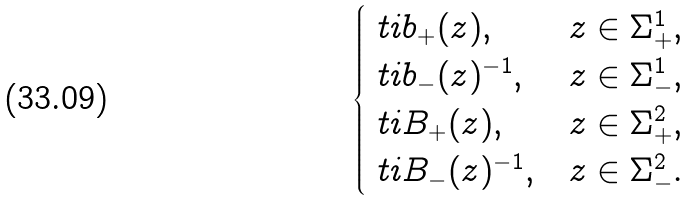Convert formula to latex. <formula><loc_0><loc_0><loc_500><loc_500>\begin{cases} \ t i { b } _ { + } ( z ) , & z \in \Sigma _ { + } ^ { 1 } , \\ \ t i { b } _ { - } ( z ) ^ { - 1 } , & z \in \Sigma _ { - } ^ { 1 } , \\ \ t i { B } _ { + } ( z ) , & z \in \Sigma _ { + } ^ { 2 } , \\ \ t i { B } _ { - } ( z ) ^ { - 1 } , & z \in \Sigma _ { - } ^ { 2 } . \end{cases}</formula> 